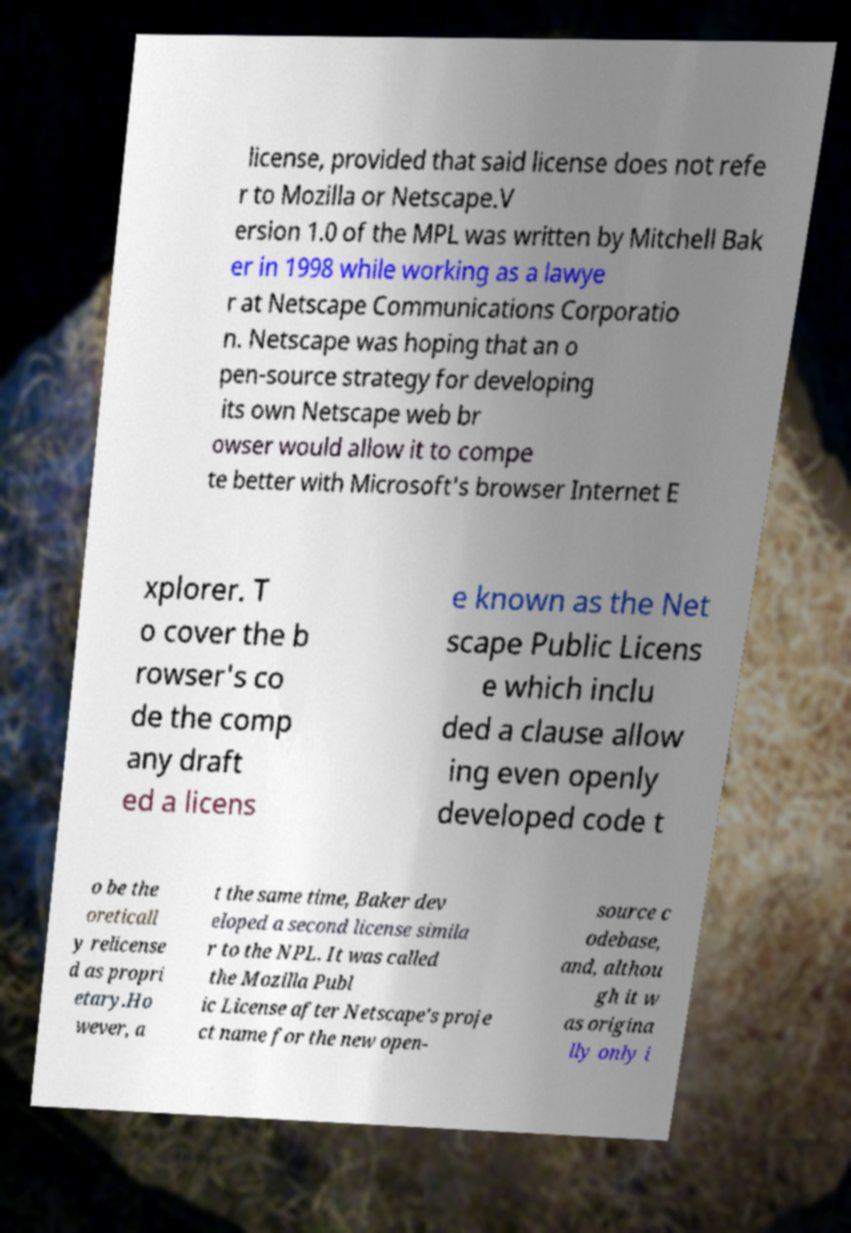Can you read and provide the text displayed in the image?This photo seems to have some interesting text. Can you extract and type it out for me? license, provided that said license does not refe r to Mozilla or Netscape.V ersion 1.0 of the MPL was written by Mitchell Bak er in 1998 while working as a lawye r at Netscape Communications Corporatio n. Netscape was hoping that an o pen-source strategy for developing its own Netscape web br owser would allow it to compe te better with Microsoft's browser Internet E xplorer. T o cover the b rowser's co de the comp any draft ed a licens e known as the Net scape Public Licens e which inclu ded a clause allow ing even openly developed code t o be the oreticall y relicense d as propri etary.Ho wever, a t the same time, Baker dev eloped a second license simila r to the NPL. It was called the Mozilla Publ ic License after Netscape's proje ct name for the new open- source c odebase, and, althou gh it w as origina lly only i 